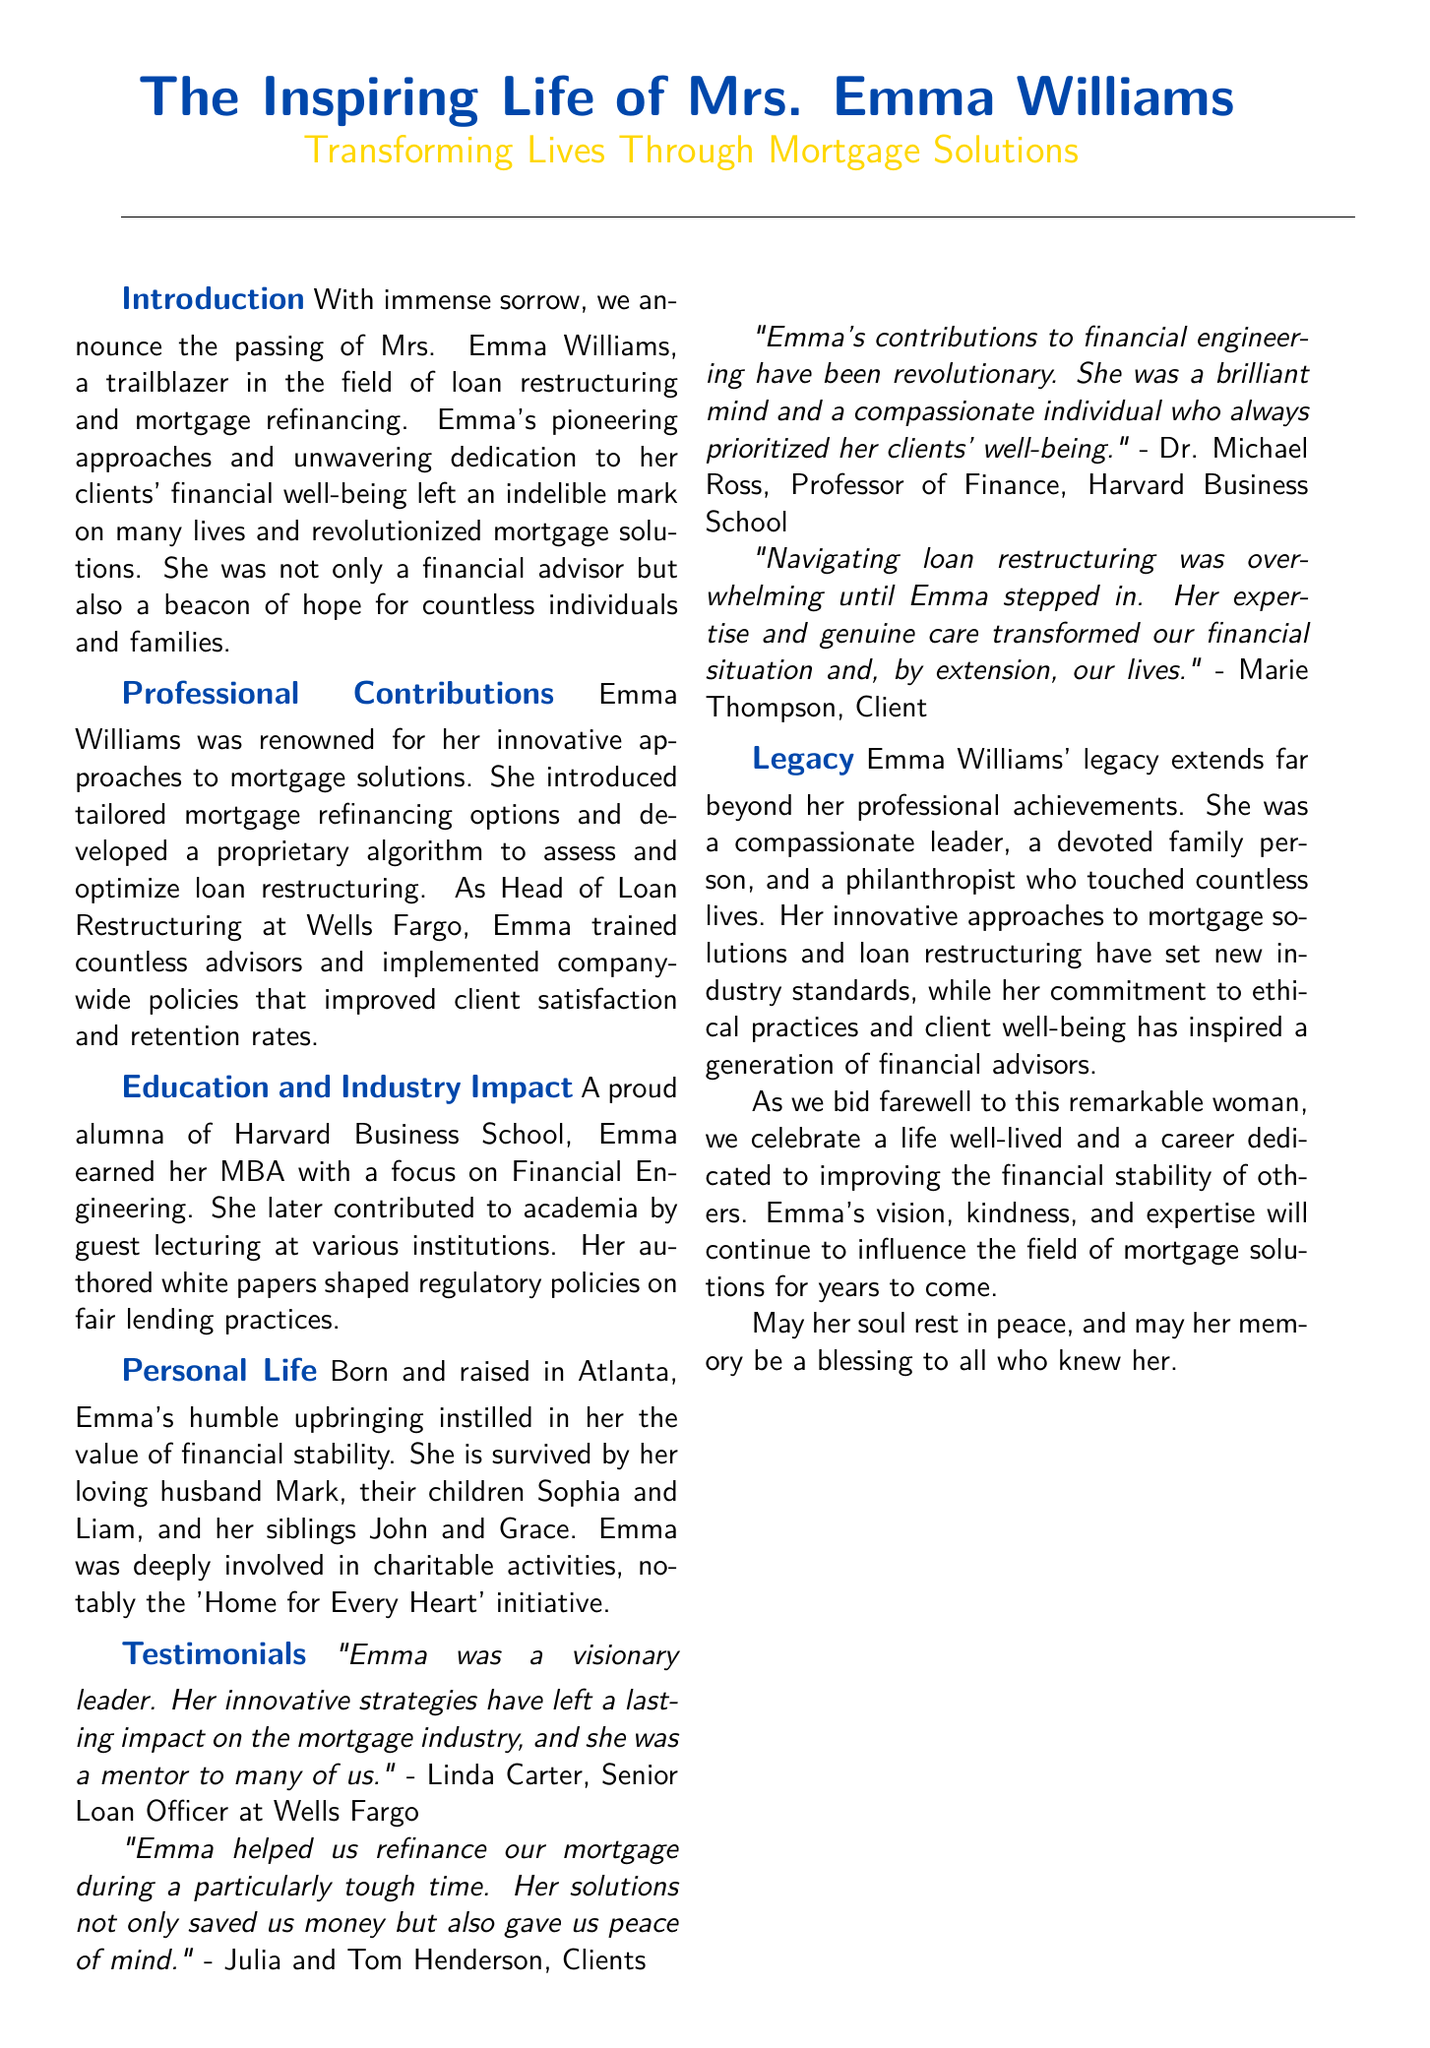What was Mrs. Emma Williams' role at Wells Fargo? Emma Williams was the Head of Loan Restructuring at Wells Fargo.
Answer: Head of Loan Restructuring What educational institution did Emma attend? Emma earned her MBA from Harvard Business School.
Answer: Harvard Business School Which charitable initiative was Emma involved with? Emma was involved in the 'Home for Every Heart' initiative.
Answer: Home for Every Heart How many children did Emma have? Emma is survived by her children Sophia and Liam.
Answer: Two What was a key focus of Emma's MBA? Emma's MBA had a focus on Financial Engineering.
Answer: Financial Engineering Who described Emma as a visionary leader? Linda Carter, a Senior Loan Officer at Wells Fargo, described Emma as a visionary leader.
Answer: Linda Carter How did Emma impact her clients according to testimonials? Emma helped clients refinance their mortgage, saving them money and providing peace of mind.
Answer: Saved money and provided peace of mind What legacy did Emma leave in the mortgage industry? Emma's innovative approaches to mortgage solutions and loan restructuring set new industry standards.
Answer: New industry standards What was Emma’s approach in her professional career? Emma introduced tailored mortgage refinancing options and developed a proprietary algorithm for loan restructuring.
Answer: Tailored mortgage refinancing options 